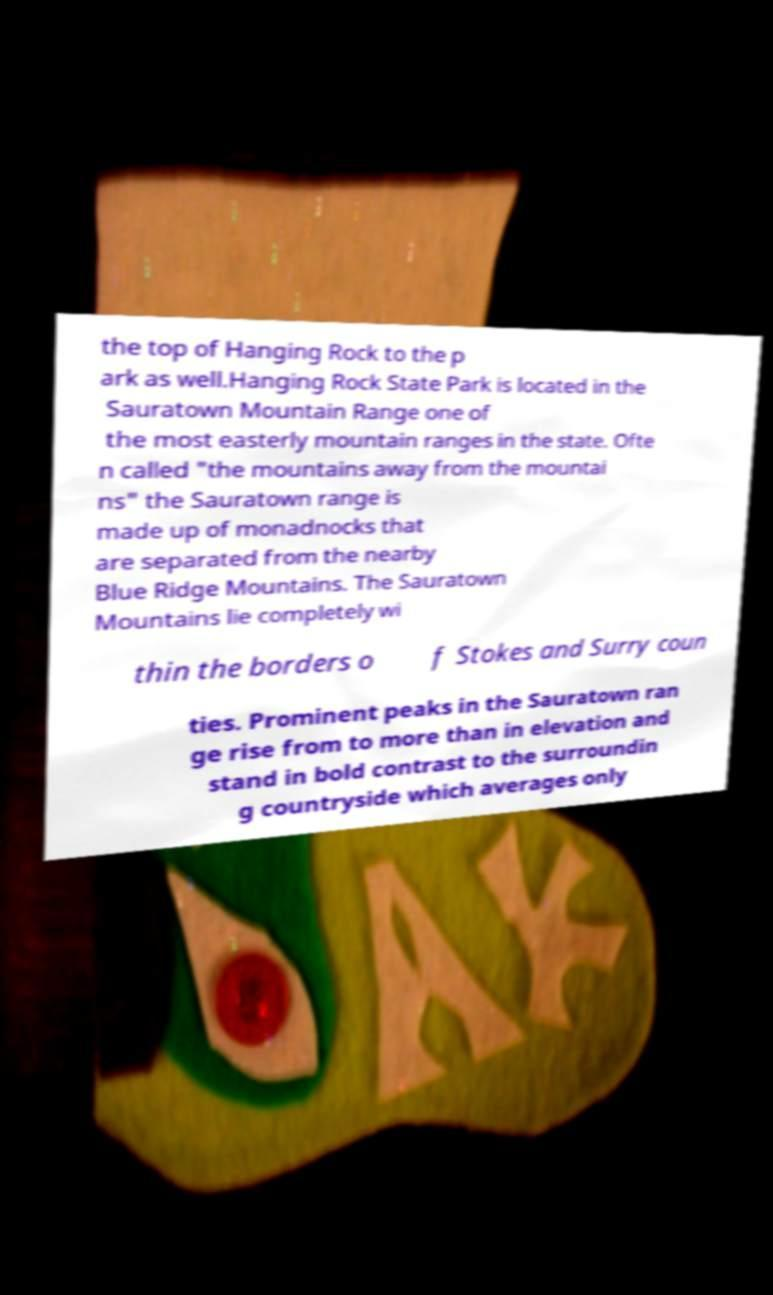For documentation purposes, I need the text within this image transcribed. Could you provide that? the top of Hanging Rock to the p ark as well.Hanging Rock State Park is located in the Sauratown Mountain Range one of the most easterly mountain ranges in the state. Ofte n called "the mountains away from the mountai ns" the Sauratown range is made up of monadnocks that are separated from the nearby Blue Ridge Mountains. The Sauratown Mountains lie completely wi thin the borders o f Stokes and Surry coun ties. Prominent peaks in the Sauratown ran ge rise from to more than in elevation and stand in bold contrast to the surroundin g countryside which averages only 